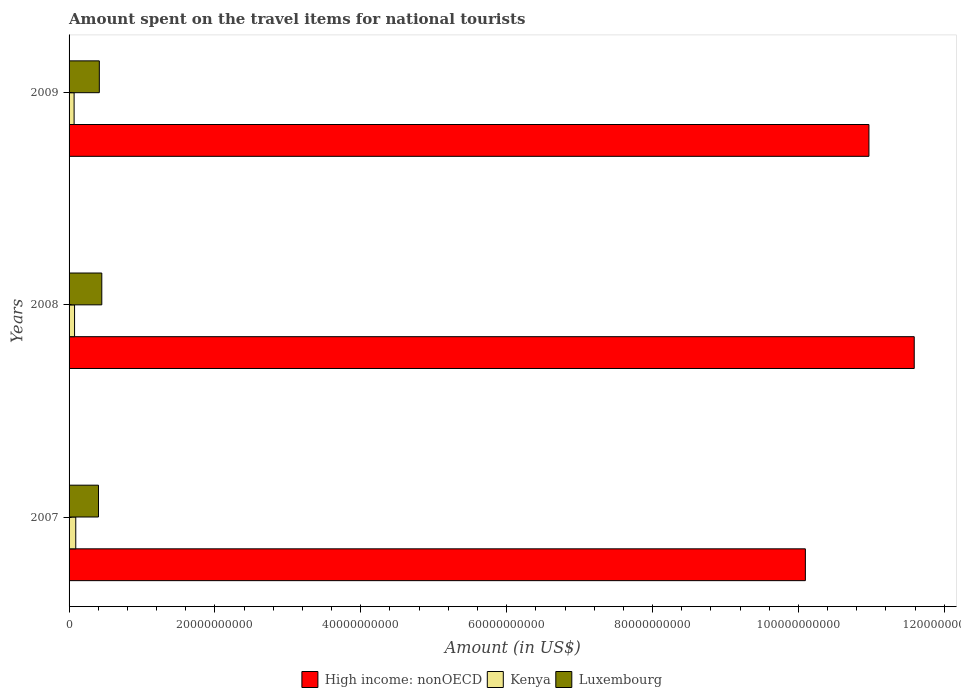How many different coloured bars are there?
Your answer should be very brief. 3. How many groups of bars are there?
Provide a short and direct response. 3. Are the number of bars per tick equal to the number of legend labels?
Offer a very short reply. Yes. Are the number of bars on each tick of the Y-axis equal?
Your answer should be very brief. Yes. How many bars are there on the 2nd tick from the top?
Offer a very short reply. 3. How many bars are there on the 2nd tick from the bottom?
Your answer should be compact. 3. What is the label of the 2nd group of bars from the top?
Provide a short and direct response. 2008. What is the amount spent on the travel items for national tourists in High income: nonOECD in 2009?
Make the answer very short. 1.10e+11. Across all years, what is the maximum amount spent on the travel items for national tourists in Kenya?
Your answer should be compact. 9.17e+08. Across all years, what is the minimum amount spent on the travel items for national tourists in High income: nonOECD?
Provide a short and direct response. 1.01e+11. In which year was the amount spent on the travel items for national tourists in Kenya minimum?
Your answer should be very brief. 2009. What is the total amount spent on the travel items for national tourists in Luxembourg in the graph?
Give a very brief answer. 1.27e+1. What is the difference between the amount spent on the travel items for national tourists in Luxembourg in 2007 and that in 2009?
Offer a very short reply. -1.16e+08. What is the difference between the amount spent on the travel items for national tourists in Kenya in 2009 and the amount spent on the travel items for national tourists in Luxembourg in 2007?
Your response must be concise. -3.34e+09. What is the average amount spent on the travel items for national tourists in Kenya per year?
Give a very brief answer. 7.86e+08. In the year 2007, what is the difference between the amount spent on the travel items for national tourists in Luxembourg and amount spent on the travel items for national tourists in High income: nonOECD?
Offer a terse response. -9.69e+1. In how many years, is the amount spent on the travel items for national tourists in Kenya greater than 8000000000 US$?
Your response must be concise. 0. What is the ratio of the amount spent on the travel items for national tourists in High income: nonOECD in 2008 to that in 2009?
Provide a short and direct response. 1.06. Is the amount spent on the travel items for national tourists in Luxembourg in 2007 less than that in 2008?
Provide a short and direct response. Yes. What is the difference between the highest and the second highest amount spent on the travel items for national tourists in Kenya?
Offer a terse response. 1.65e+08. What is the difference between the highest and the lowest amount spent on the travel items for national tourists in Kenya?
Your response must be concise. 2.27e+08. In how many years, is the amount spent on the travel items for national tourists in Luxembourg greater than the average amount spent on the travel items for national tourists in Luxembourg taken over all years?
Make the answer very short. 1. Is the sum of the amount spent on the travel items for national tourists in Kenya in 2008 and 2009 greater than the maximum amount spent on the travel items for national tourists in High income: nonOECD across all years?
Offer a very short reply. No. What does the 2nd bar from the top in 2007 represents?
Your answer should be very brief. Kenya. What does the 2nd bar from the bottom in 2009 represents?
Offer a very short reply. Kenya. Is it the case that in every year, the sum of the amount spent on the travel items for national tourists in Kenya and amount spent on the travel items for national tourists in High income: nonOECD is greater than the amount spent on the travel items for national tourists in Luxembourg?
Your response must be concise. Yes. How many bars are there?
Provide a succinct answer. 9. What is the difference between two consecutive major ticks on the X-axis?
Your response must be concise. 2.00e+1. Are the values on the major ticks of X-axis written in scientific E-notation?
Give a very brief answer. No. Does the graph contain grids?
Provide a short and direct response. No. Where does the legend appear in the graph?
Give a very brief answer. Bottom center. How many legend labels are there?
Make the answer very short. 3. How are the legend labels stacked?
Ensure brevity in your answer.  Horizontal. What is the title of the graph?
Provide a short and direct response. Amount spent on the travel items for national tourists. Does "Belarus" appear as one of the legend labels in the graph?
Make the answer very short. No. What is the label or title of the Y-axis?
Keep it short and to the point. Years. What is the Amount (in US$) of High income: nonOECD in 2007?
Keep it short and to the point. 1.01e+11. What is the Amount (in US$) in Kenya in 2007?
Ensure brevity in your answer.  9.17e+08. What is the Amount (in US$) in Luxembourg in 2007?
Offer a terse response. 4.03e+09. What is the Amount (in US$) in High income: nonOECD in 2008?
Give a very brief answer. 1.16e+11. What is the Amount (in US$) of Kenya in 2008?
Your answer should be very brief. 7.52e+08. What is the Amount (in US$) in Luxembourg in 2008?
Provide a short and direct response. 4.49e+09. What is the Amount (in US$) of High income: nonOECD in 2009?
Keep it short and to the point. 1.10e+11. What is the Amount (in US$) in Kenya in 2009?
Provide a succinct answer. 6.90e+08. What is the Amount (in US$) of Luxembourg in 2009?
Your answer should be compact. 4.15e+09. Across all years, what is the maximum Amount (in US$) of High income: nonOECD?
Provide a succinct answer. 1.16e+11. Across all years, what is the maximum Amount (in US$) in Kenya?
Your answer should be very brief. 9.17e+08. Across all years, what is the maximum Amount (in US$) of Luxembourg?
Keep it short and to the point. 4.49e+09. Across all years, what is the minimum Amount (in US$) of High income: nonOECD?
Give a very brief answer. 1.01e+11. Across all years, what is the minimum Amount (in US$) of Kenya?
Provide a succinct answer. 6.90e+08. Across all years, what is the minimum Amount (in US$) of Luxembourg?
Your answer should be compact. 4.03e+09. What is the total Amount (in US$) of High income: nonOECD in the graph?
Your answer should be very brief. 3.27e+11. What is the total Amount (in US$) of Kenya in the graph?
Keep it short and to the point. 2.36e+09. What is the total Amount (in US$) of Luxembourg in the graph?
Provide a short and direct response. 1.27e+1. What is the difference between the Amount (in US$) in High income: nonOECD in 2007 and that in 2008?
Keep it short and to the point. -1.49e+1. What is the difference between the Amount (in US$) in Kenya in 2007 and that in 2008?
Keep it short and to the point. 1.65e+08. What is the difference between the Amount (in US$) of Luxembourg in 2007 and that in 2008?
Keep it short and to the point. -4.54e+08. What is the difference between the Amount (in US$) in High income: nonOECD in 2007 and that in 2009?
Your answer should be compact. -8.72e+09. What is the difference between the Amount (in US$) of Kenya in 2007 and that in 2009?
Keep it short and to the point. 2.27e+08. What is the difference between the Amount (in US$) of Luxembourg in 2007 and that in 2009?
Offer a very short reply. -1.16e+08. What is the difference between the Amount (in US$) of High income: nonOECD in 2008 and that in 2009?
Offer a terse response. 6.21e+09. What is the difference between the Amount (in US$) in Kenya in 2008 and that in 2009?
Offer a terse response. 6.20e+07. What is the difference between the Amount (in US$) of Luxembourg in 2008 and that in 2009?
Your answer should be very brief. 3.38e+08. What is the difference between the Amount (in US$) of High income: nonOECD in 2007 and the Amount (in US$) of Kenya in 2008?
Make the answer very short. 1.00e+11. What is the difference between the Amount (in US$) of High income: nonOECD in 2007 and the Amount (in US$) of Luxembourg in 2008?
Provide a succinct answer. 9.65e+1. What is the difference between the Amount (in US$) of Kenya in 2007 and the Amount (in US$) of Luxembourg in 2008?
Make the answer very short. -3.57e+09. What is the difference between the Amount (in US$) of High income: nonOECD in 2007 and the Amount (in US$) of Kenya in 2009?
Offer a very short reply. 1.00e+11. What is the difference between the Amount (in US$) of High income: nonOECD in 2007 and the Amount (in US$) of Luxembourg in 2009?
Offer a terse response. 9.68e+1. What is the difference between the Amount (in US$) of Kenya in 2007 and the Amount (in US$) of Luxembourg in 2009?
Keep it short and to the point. -3.23e+09. What is the difference between the Amount (in US$) in High income: nonOECD in 2008 and the Amount (in US$) in Kenya in 2009?
Offer a very short reply. 1.15e+11. What is the difference between the Amount (in US$) of High income: nonOECD in 2008 and the Amount (in US$) of Luxembourg in 2009?
Offer a very short reply. 1.12e+11. What is the difference between the Amount (in US$) in Kenya in 2008 and the Amount (in US$) in Luxembourg in 2009?
Ensure brevity in your answer.  -3.40e+09. What is the average Amount (in US$) of High income: nonOECD per year?
Ensure brevity in your answer.  1.09e+11. What is the average Amount (in US$) in Kenya per year?
Keep it short and to the point. 7.86e+08. What is the average Amount (in US$) in Luxembourg per year?
Your answer should be very brief. 4.22e+09. In the year 2007, what is the difference between the Amount (in US$) in High income: nonOECD and Amount (in US$) in Kenya?
Offer a very short reply. 1.00e+11. In the year 2007, what is the difference between the Amount (in US$) in High income: nonOECD and Amount (in US$) in Luxembourg?
Keep it short and to the point. 9.69e+1. In the year 2007, what is the difference between the Amount (in US$) in Kenya and Amount (in US$) in Luxembourg?
Offer a very short reply. -3.12e+09. In the year 2008, what is the difference between the Amount (in US$) in High income: nonOECD and Amount (in US$) in Kenya?
Your answer should be compact. 1.15e+11. In the year 2008, what is the difference between the Amount (in US$) of High income: nonOECD and Amount (in US$) of Luxembourg?
Your answer should be very brief. 1.11e+11. In the year 2008, what is the difference between the Amount (in US$) in Kenya and Amount (in US$) in Luxembourg?
Your response must be concise. -3.73e+09. In the year 2009, what is the difference between the Amount (in US$) of High income: nonOECD and Amount (in US$) of Kenya?
Ensure brevity in your answer.  1.09e+11. In the year 2009, what is the difference between the Amount (in US$) of High income: nonOECD and Amount (in US$) of Luxembourg?
Keep it short and to the point. 1.06e+11. In the year 2009, what is the difference between the Amount (in US$) in Kenya and Amount (in US$) in Luxembourg?
Offer a very short reply. -3.46e+09. What is the ratio of the Amount (in US$) of High income: nonOECD in 2007 to that in 2008?
Your answer should be very brief. 0.87. What is the ratio of the Amount (in US$) of Kenya in 2007 to that in 2008?
Make the answer very short. 1.22. What is the ratio of the Amount (in US$) in Luxembourg in 2007 to that in 2008?
Keep it short and to the point. 0.9. What is the ratio of the Amount (in US$) in High income: nonOECD in 2007 to that in 2009?
Your answer should be very brief. 0.92. What is the ratio of the Amount (in US$) in Kenya in 2007 to that in 2009?
Offer a terse response. 1.33. What is the ratio of the Amount (in US$) of Luxembourg in 2007 to that in 2009?
Give a very brief answer. 0.97. What is the ratio of the Amount (in US$) in High income: nonOECD in 2008 to that in 2009?
Give a very brief answer. 1.06. What is the ratio of the Amount (in US$) in Kenya in 2008 to that in 2009?
Provide a succinct answer. 1.09. What is the ratio of the Amount (in US$) of Luxembourg in 2008 to that in 2009?
Offer a very short reply. 1.08. What is the difference between the highest and the second highest Amount (in US$) of High income: nonOECD?
Keep it short and to the point. 6.21e+09. What is the difference between the highest and the second highest Amount (in US$) in Kenya?
Offer a very short reply. 1.65e+08. What is the difference between the highest and the second highest Amount (in US$) in Luxembourg?
Keep it short and to the point. 3.38e+08. What is the difference between the highest and the lowest Amount (in US$) in High income: nonOECD?
Provide a succinct answer. 1.49e+1. What is the difference between the highest and the lowest Amount (in US$) of Kenya?
Your answer should be compact. 2.27e+08. What is the difference between the highest and the lowest Amount (in US$) of Luxembourg?
Your answer should be compact. 4.54e+08. 